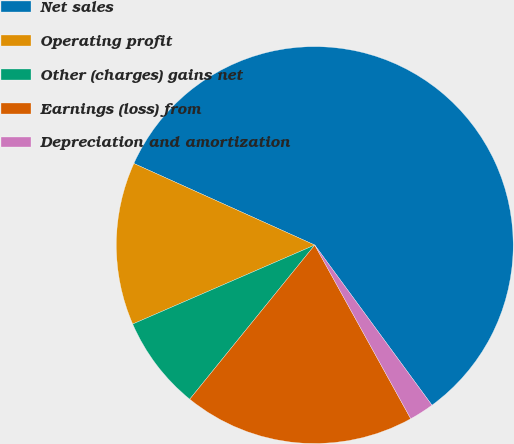Convert chart to OTSL. <chart><loc_0><loc_0><loc_500><loc_500><pie_chart><fcel>Net sales<fcel>Operating profit<fcel>Other (charges) gains net<fcel>Earnings (loss) from<fcel>Depreciation and amortization<nl><fcel>58.2%<fcel>13.26%<fcel>7.64%<fcel>18.88%<fcel>2.02%<nl></chart> 